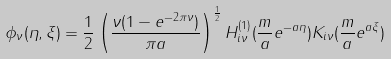<formula> <loc_0><loc_0><loc_500><loc_500>\phi _ { \nu } ( \eta , \xi ) = \frac { 1 } { 2 } \left ( \frac { \nu ( 1 - e ^ { - 2 \pi \nu } ) } { \pi a } \right ) ^ { \frac { 1 } { 2 } } H ^ { ( 1 ) } _ { i \nu } ( \frac { m } { a } e ^ { - a \eta } ) K _ { i \nu } ( \frac { m } { a } e ^ { a \xi } )</formula> 